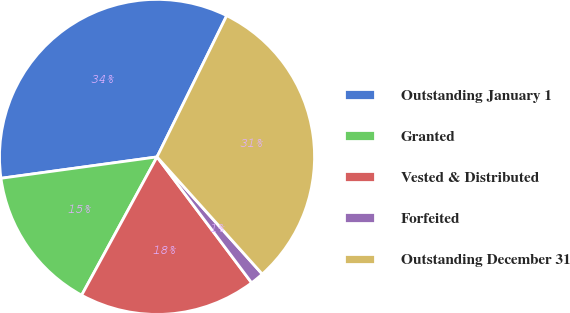Convert chart. <chart><loc_0><loc_0><loc_500><loc_500><pie_chart><fcel>Outstanding January 1<fcel>Granted<fcel>Vested & Distributed<fcel>Forfeited<fcel>Outstanding December 31<nl><fcel>34.46%<fcel>14.89%<fcel>18.2%<fcel>1.39%<fcel>31.06%<nl></chart> 